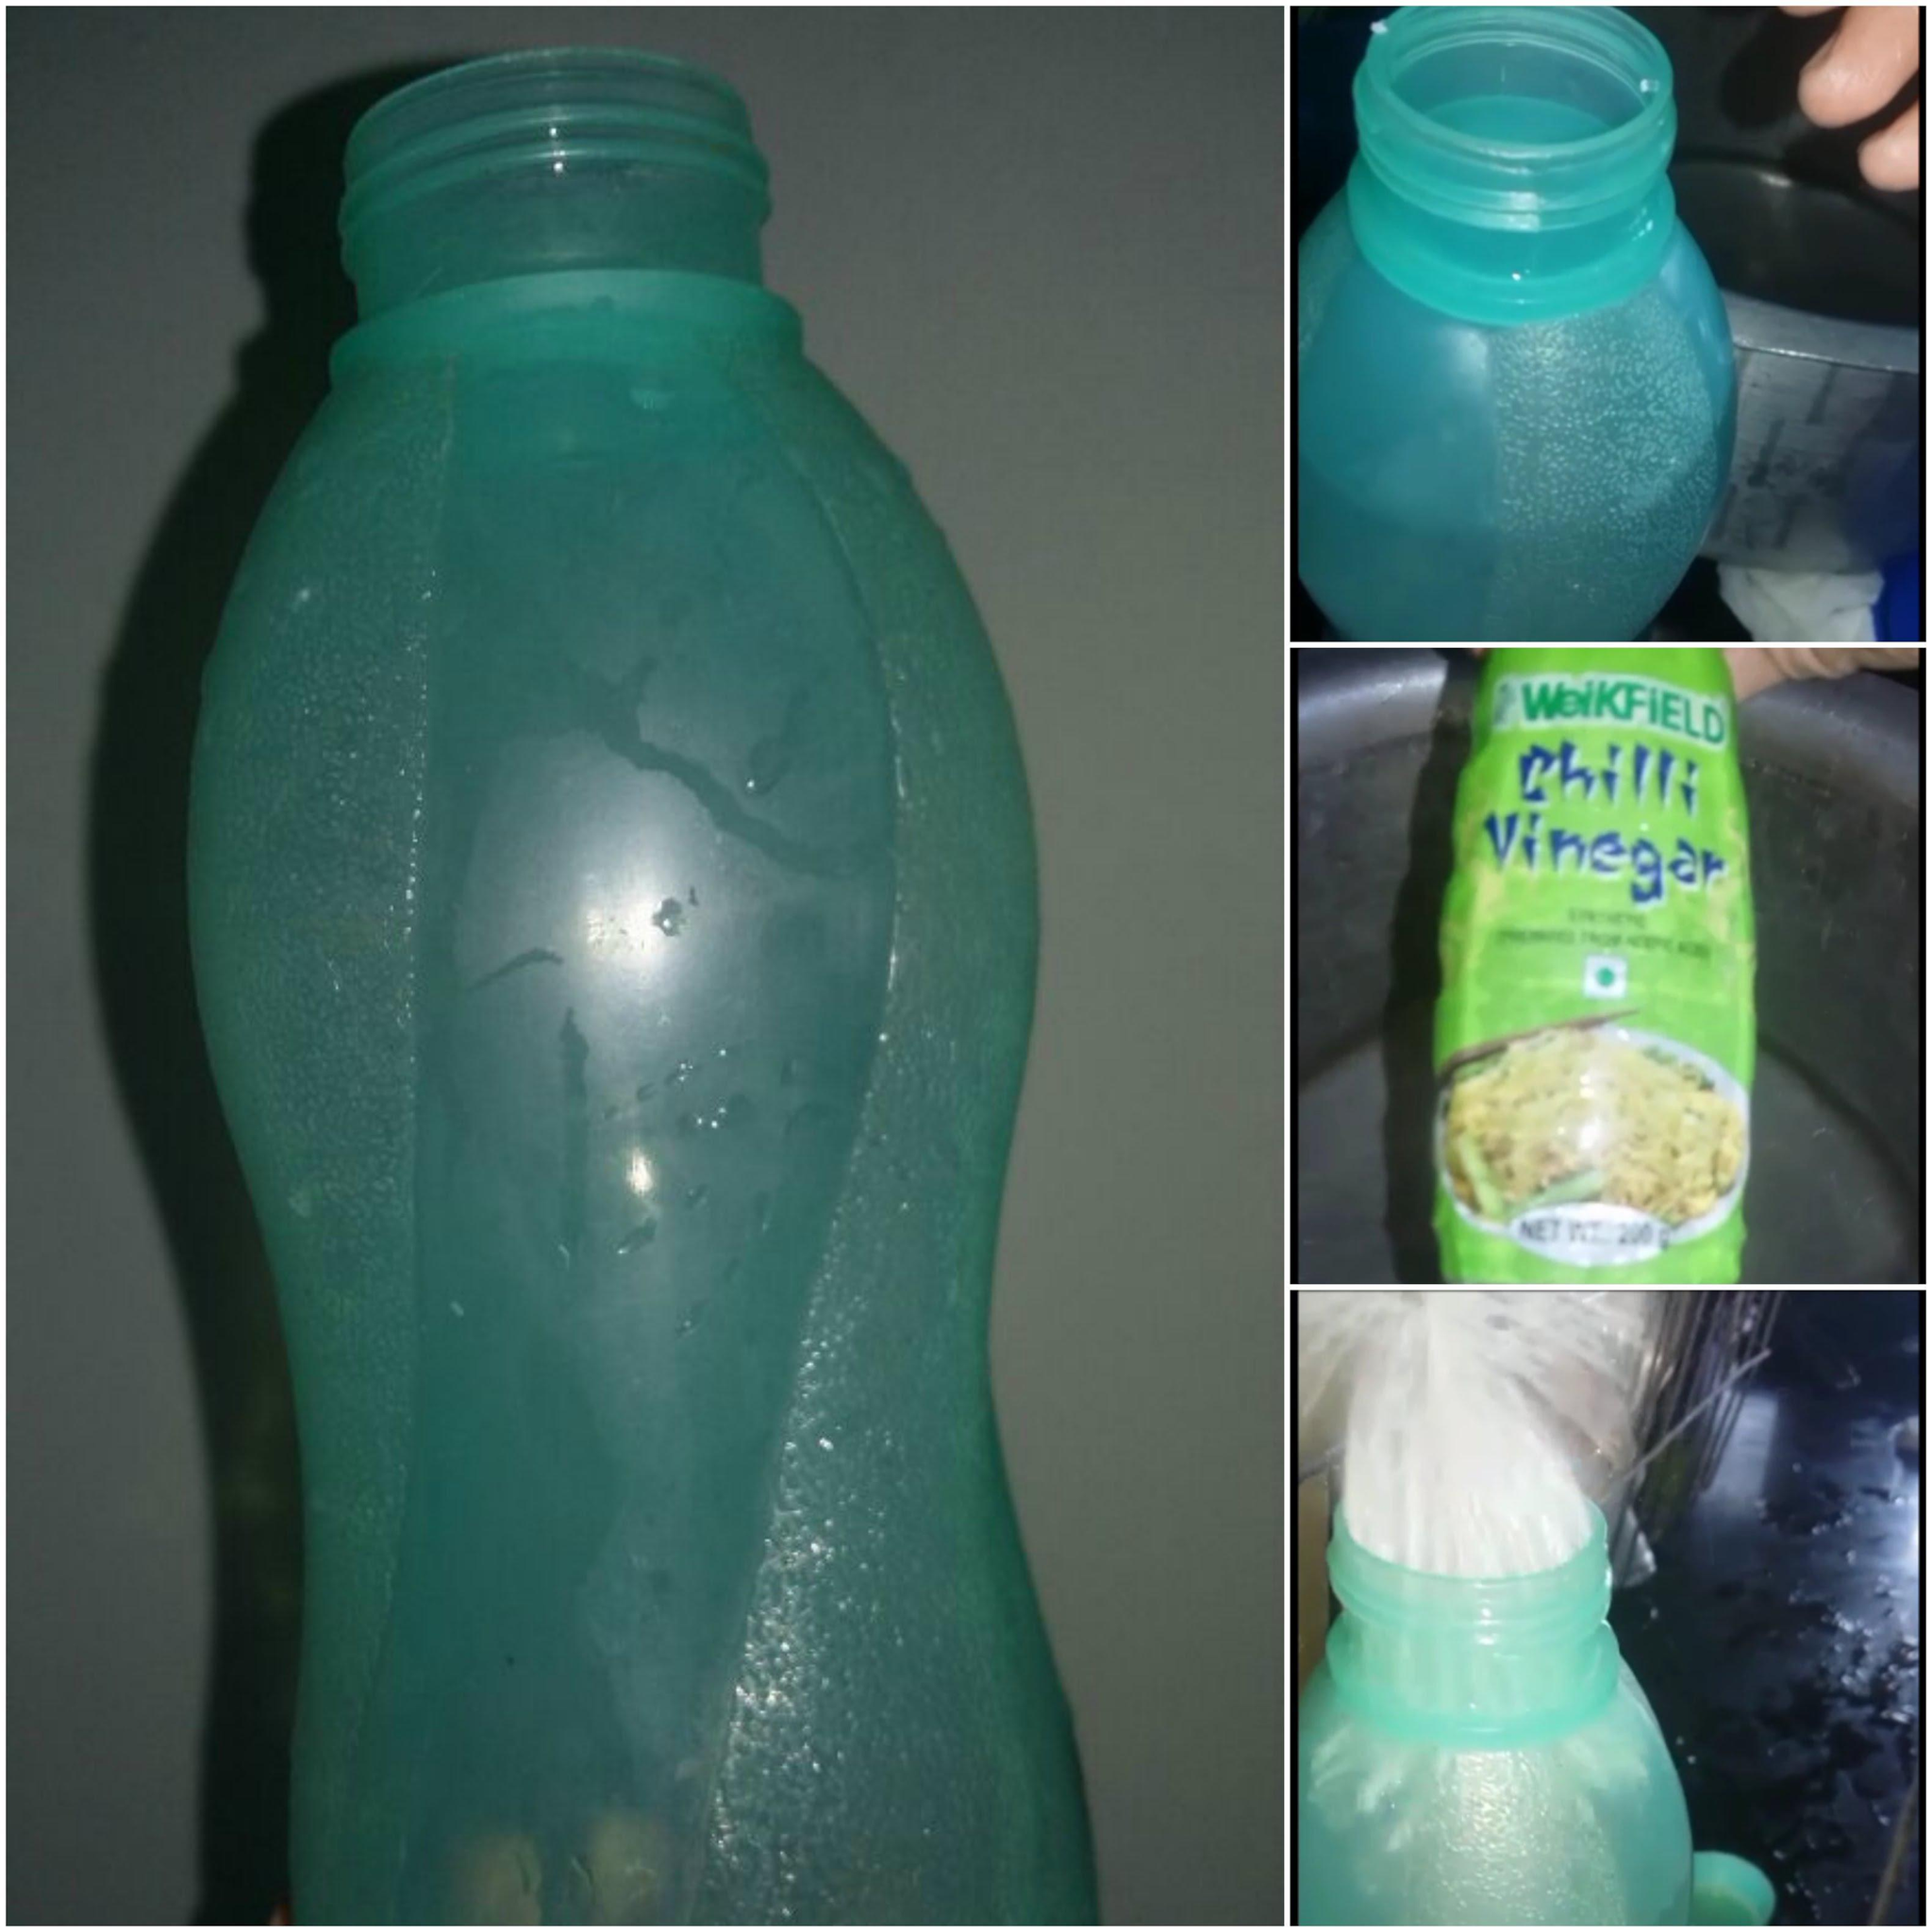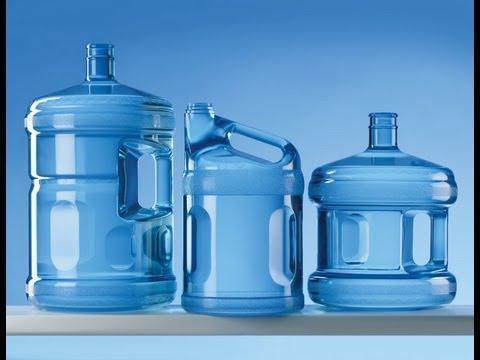The first image is the image on the left, the second image is the image on the right. Examine the images to the left and right. Is the description "In at least one image there are at least two plastic bottles with no lids." accurate? Answer yes or no. Yes. 